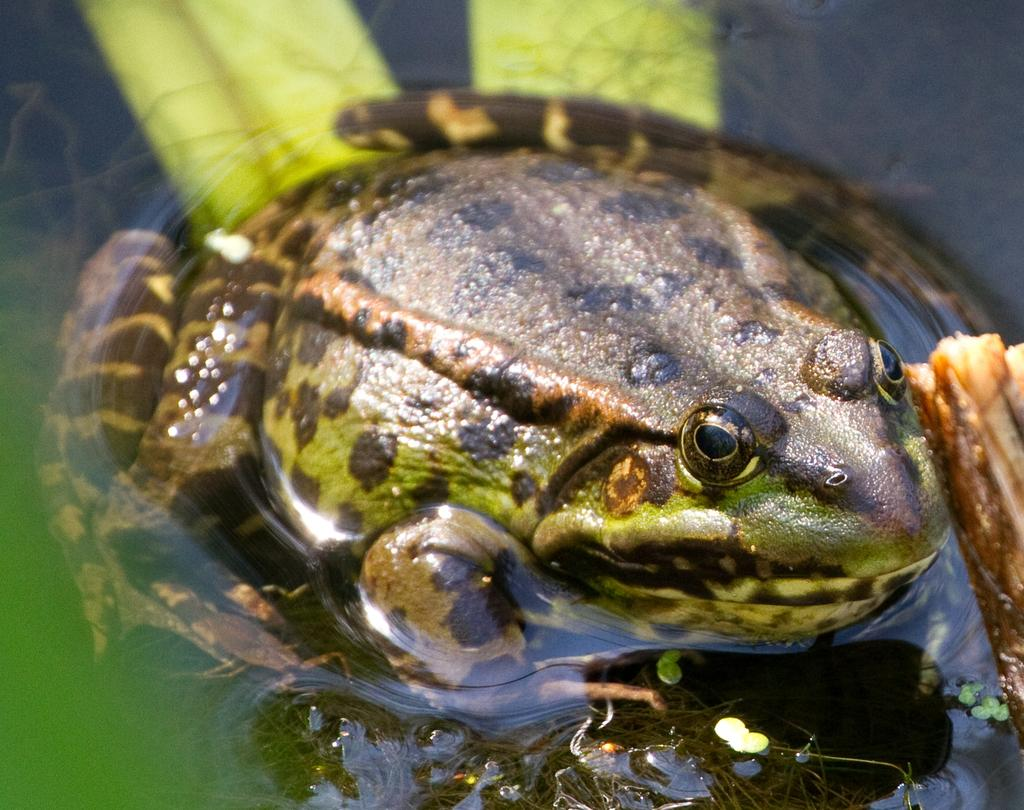What type of animal is in the image? There is a green frog in the image. Where is the green frog located? The green frog is in the water. What type of knife is the green frog using to cut down trees in the image? There is no knife or trees present in the image; it only features a green frog in the water. 